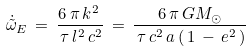Convert formula to latex. <formula><loc_0><loc_0><loc_500><loc_500>\dot { \tilde { \omega } } _ { E } \, = \, \frac { 6 \, \pi \, k ^ { 2 } \, } { \, \tau \, l ^ { 2 } \, c ^ { 2 } } \, = \, \frac { 6 \, \pi \, G M _ { \odot } } { \, \tau \, c ^ { 2 } \, a \, ( \, 1 \, - \, e ^ { 2 } \, ) }</formula> 